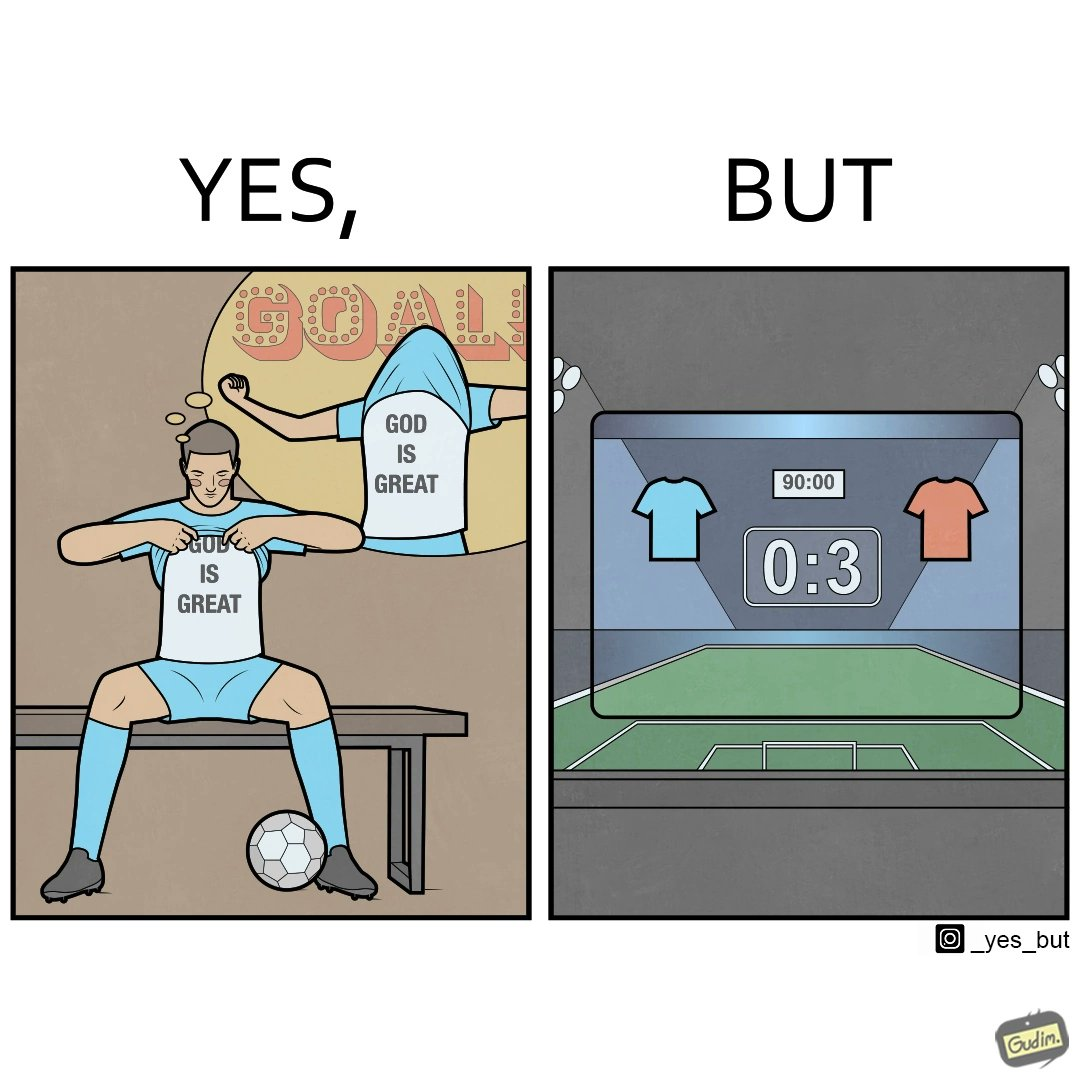Describe what you see in this image. The image is funny because the player thinks that when he scores a goal he will thank the god and show his t-shirt saying "GOD IS GREAT" but he ends up not being able to score any goals meaning that God did not want him to score any goals. 